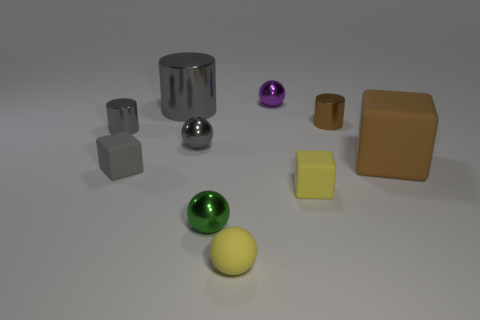Subtract all spheres. How many objects are left? 6 Add 5 gray rubber cubes. How many gray rubber cubes are left? 6 Add 2 yellow rubber cubes. How many yellow rubber cubes exist? 3 Subtract 0 cyan blocks. How many objects are left? 10 Subtract all big purple shiny spheres. Subtract all tiny gray things. How many objects are left? 7 